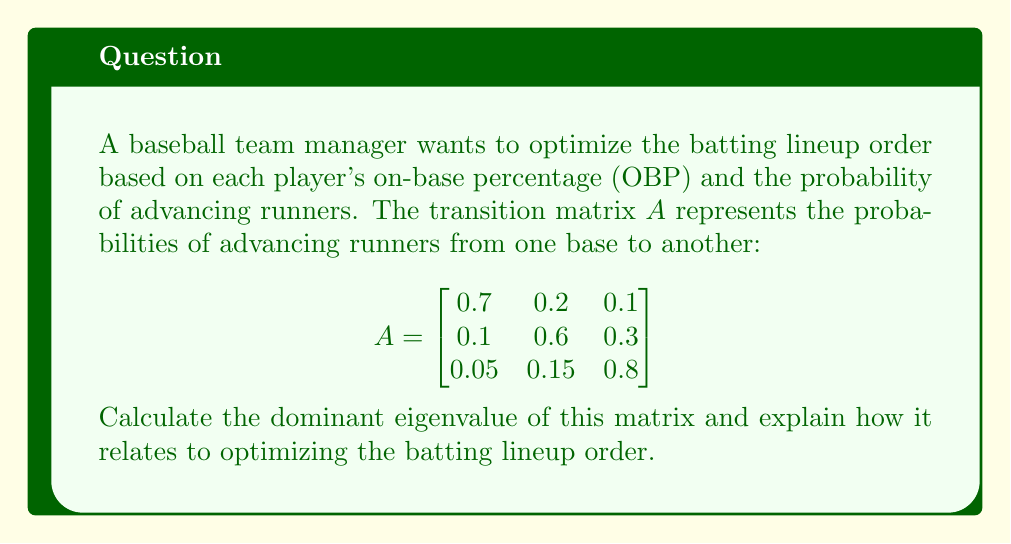Solve this math problem. To optimize the batting lineup order using eigenvectors and eigenvalues, we need to find the dominant eigenvalue of the transition matrix A. This value represents the long-term effectiveness of the lineup in advancing runners.

Step 1: Find the characteristic equation of matrix A.
$$\det(A - \lambda I) = 0$$
$$\begin{vmatrix}
0.7 - \lambda & 0.2 & 0.1 \\
0.1 & 0.6 - \lambda & 0.3 \\
0.05 & 0.15 & 0.8 - \lambda
\end{vmatrix} = 0$$

Step 2: Expand the determinant.
$$(0.7 - \lambda)[(0.6 - \lambda)(0.8 - \lambda) - 0.045] - 0.2[0.1(0.8 - \lambda) - 0.015] + 0.1[0.1(0.15) - 0.05(0.6 - \lambda)] = 0$$

Step 3: Simplify the equation.
$$-\lambda^3 + 2.1\lambda^2 - 1.435\lambda + 0.32 = 0$$

Step 4: Solve the cubic equation using numerical methods or a calculator.

The three eigenvalues are approximately:
$\lambda_1 \approx 0.9053$
$\lambda_2 \approx 0.6166$
$\lambda_3 \approx 0.5781$

The dominant eigenvalue is the largest one: $\lambda_1 \approx 0.9053$

Step 5: Interpret the result.
The dominant eigenvalue of 0.9053 indicates that, in the long run, this batting lineup will advance runners at a rate of about 90.53% per at-bat. This value can be used to compare different lineup configurations. A higher dominant eigenvalue suggests a more effective lineup in terms of advancing runners and potentially scoring more runs.

To optimize the batting lineup order, the manager should arrange players to maximize this dominant eigenvalue. Players with higher OBPs and better ability to advance runners should be placed in positions that maximize the overall effectiveness of the lineup, as represented by the dominant eigenvalue.
Answer: $\lambda_1 \approx 0.9053$ 